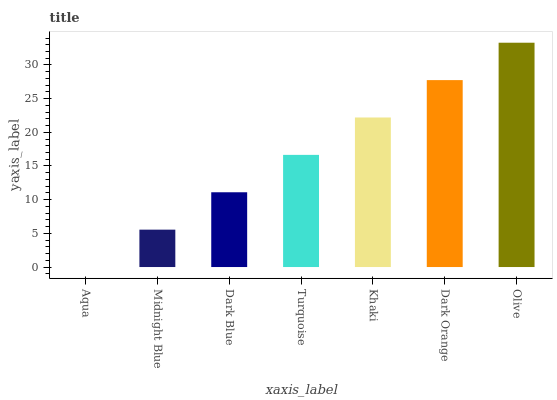Is Aqua the minimum?
Answer yes or no. Yes. Is Olive the maximum?
Answer yes or no. Yes. Is Midnight Blue the minimum?
Answer yes or no. No. Is Midnight Blue the maximum?
Answer yes or no. No. Is Midnight Blue greater than Aqua?
Answer yes or no. Yes. Is Aqua less than Midnight Blue?
Answer yes or no. Yes. Is Aqua greater than Midnight Blue?
Answer yes or no. No. Is Midnight Blue less than Aqua?
Answer yes or no. No. Is Turquoise the high median?
Answer yes or no. Yes. Is Turquoise the low median?
Answer yes or no. Yes. Is Dark Orange the high median?
Answer yes or no. No. Is Olive the low median?
Answer yes or no. No. 